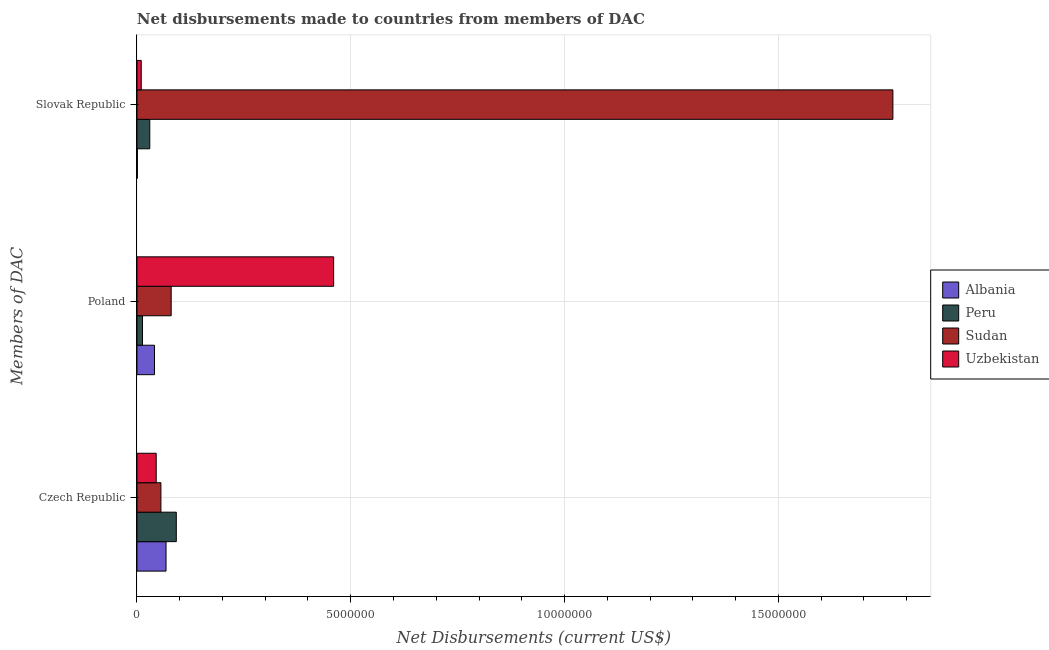Are the number of bars on each tick of the Y-axis equal?
Keep it short and to the point. Yes. What is the label of the 3rd group of bars from the top?
Keep it short and to the point. Czech Republic. What is the net disbursements made by slovak republic in Uzbekistan?
Provide a short and direct response. 1.00e+05. Across all countries, what is the maximum net disbursements made by czech republic?
Ensure brevity in your answer.  9.20e+05. Across all countries, what is the minimum net disbursements made by czech republic?
Your answer should be very brief. 4.50e+05. In which country was the net disbursements made by slovak republic maximum?
Your answer should be compact. Sudan. What is the total net disbursements made by czech republic in the graph?
Make the answer very short. 2.61e+06. What is the difference between the net disbursements made by poland in Sudan and that in Albania?
Your response must be concise. 3.90e+05. What is the difference between the net disbursements made by slovak republic in Peru and the net disbursements made by poland in Sudan?
Offer a terse response. -5.00e+05. What is the average net disbursements made by czech republic per country?
Give a very brief answer. 6.52e+05. What is the difference between the net disbursements made by czech republic and net disbursements made by slovak republic in Albania?
Your response must be concise. 6.70e+05. In how many countries, is the net disbursements made by slovak republic greater than 15000000 US$?
Offer a very short reply. 1. What is the ratio of the net disbursements made by slovak republic in Albania to that in Sudan?
Your answer should be very brief. 0. What is the difference between the highest and the lowest net disbursements made by czech republic?
Your response must be concise. 4.70e+05. In how many countries, is the net disbursements made by czech republic greater than the average net disbursements made by czech republic taken over all countries?
Provide a short and direct response. 2. Is the sum of the net disbursements made by poland in Peru and Albania greater than the maximum net disbursements made by slovak republic across all countries?
Your answer should be compact. No. What does the 1st bar from the top in Poland represents?
Make the answer very short. Uzbekistan. What does the 1st bar from the bottom in Czech Republic represents?
Ensure brevity in your answer.  Albania. Is it the case that in every country, the sum of the net disbursements made by czech republic and net disbursements made by poland is greater than the net disbursements made by slovak republic?
Provide a succinct answer. No. How many bars are there?
Provide a succinct answer. 12. Are all the bars in the graph horizontal?
Provide a succinct answer. Yes. Are the values on the major ticks of X-axis written in scientific E-notation?
Make the answer very short. No. Where does the legend appear in the graph?
Your response must be concise. Center right. What is the title of the graph?
Make the answer very short. Net disbursements made to countries from members of DAC. What is the label or title of the X-axis?
Provide a succinct answer. Net Disbursements (current US$). What is the label or title of the Y-axis?
Provide a succinct answer. Members of DAC. What is the Net Disbursements (current US$) in Albania in Czech Republic?
Make the answer very short. 6.80e+05. What is the Net Disbursements (current US$) in Peru in Czech Republic?
Your response must be concise. 9.20e+05. What is the Net Disbursements (current US$) of Sudan in Czech Republic?
Make the answer very short. 5.60e+05. What is the Net Disbursements (current US$) of Uzbekistan in Czech Republic?
Keep it short and to the point. 4.50e+05. What is the Net Disbursements (current US$) of Albania in Poland?
Your answer should be very brief. 4.10e+05. What is the Net Disbursements (current US$) in Peru in Poland?
Provide a succinct answer. 1.30e+05. What is the Net Disbursements (current US$) in Uzbekistan in Poland?
Your answer should be compact. 4.60e+06. What is the Net Disbursements (current US$) of Peru in Slovak Republic?
Your answer should be compact. 3.00e+05. What is the Net Disbursements (current US$) of Sudan in Slovak Republic?
Your answer should be compact. 1.77e+07. Across all Members of DAC, what is the maximum Net Disbursements (current US$) in Albania?
Offer a very short reply. 6.80e+05. Across all Members of DAC, what is the maximum Net Disbursements (current US$) in Peru?
Offer a very short reply. 9.20e+05. Across all Members of DAC, what is the maximum Net Disbursements (current US$) in Sudan?
Provide a short and direct response. 1.77e+07. Across all Members of DAC, what is the maximum Net Disbursements (current US$) in Uzbekistan?
Make the answer very short. 4.60e+06. Across all Members of DAC, what is the minimum Net Disbursements (current US$) of Albania?
Offer a terse response. 10000. Across all Members of DAC, what is the minimum Net Disbursements (current US$) of Sudan?
Provide a short and direct response. 5.60e+05. Across all Members of DAC, what is the minimum Net Disbursements (current US$) in Uzbekistan?
Ensure brevity in your answer.  1.00e+05. What is the total Net Disbursements (current US$) of Albania in the graph?
Provide a short and direct response. 1.10e+06. What is the total Net Disbursements (current US$) in Peru in the graph?
Your answer should be compact. 1.35e+06. What is the total Net Disbursements (current US$) of Sudan in the graph?
Give a very brief answer. 1.90e+07. What is the total Net Disbursements (current US$) of Uzbekistan in the graph?
Keep it short and to the point. 5.15e+06. What is the difference between the Net Disbursements (current US$) in Albania in Czech Republic and that in Poland?
Your answer should be compact. 2.70e+05. What is the difference between the Net Disbursements (current US$) in Peru in Czech Republic and that in Poland?
Offer a terse response. 7.90e+05. What is the difference between the Net Disbursements (current US$) of Uzbekistan in Czech Republic and that in Poland?
Offer a very short reply. -4.15e+06. What is the difference between the Net Disbursements (current US$) of Albania in Czech Republic and that in Slovak Republic?
Provide a succinct answer. 6.70e+05. What is the difference between the Net Disbursements (current US$) of Peru in Czech Republic and that in Slovak Republic?
Keep it short and to the point. 6.20e+05. What is the difference between the Net Disbursements (current US$) in Sudan in Czech Republic and that in Slovak Republic?
Keep it short and to the point. -1.71e+07. What is the difference between the Net Disbursements (current US$) in Uzbekistan in Czech Republic and that in Slovak Republic?
Make the answer very short. 3.50e+05. What is the difference between the Net Disbursements (current US$) in Albania in Poland and that in Slovak Republic?
Provide a short and direct response. 4.00e+05. What is the difference between the Net Disbursements (current US$) in Peru in Poland and that in Slovak Republic?
Keep it short and to the point. -1.70e+05. What is the difference between the Net Disbursements (current US$) in Sudan in Poland and that in Slovak Republic?
Offer a very short reply. -1.69e+07. What is the difference between the Net Disbursements (current US$) in Uzbekistan in Poland and that in Slovak Republic?
Provide a short and direct response. 4.50e+06. What is the difference between the Net Disbursements (current US$) in Albania in Czech Republic and the Net Disbursements (current US$) in Peru in Poland?
Offer a terse response. 5.50e+05. What is the difference between the Net Disbursements (current US$) in Albania in Czech Republic and the Net Disbursements (current US$) in Uzbekistan in Poland?
Ensure brevity in your answer.  -3.92e+06. What is the difference between the Net Disbursements (current US$) in Peru in Czech Republic and the Net Disbursements (current US$) in Sudan in Poland?
Give a very brief answer. 1.20e+05. What is the difference between the Net Disbursements (current US$) in Peru in Czech Republic and the Net Disbursements (current US$) in Uzbekistan in Poland?
Provide a succinct answer. -3.68e+06. What is the difference between the Net Disbursements (current US$) of Sudan in Czech Republic and the Net Disbursements (current US$) of Uzbekistan in Poland?
Offer a terse response. -4.04e+06. What is the difference between the Net Disbursements (current US$) of Albania in Czech Republic and the Net Disbursements (current US$) of Peru in Slovak Republic?
Make the answer very short. 3.80e+05. What is the difference between the Net Disbursements (current US$) of Albania in Czech Republic and the Net Disbursements (current US$) of Sudan in Slovak Republic?
Provide a succinct answer. -1.70e+07. What is the difference between the Net Disbursements (current US$) in Albania in Czech Republic and the Net Disbursements (current US$) in Uzbekistan in Slovak Republic?
Make the answer very short. 5.80e+05. What is the difference between the Net Disbursements (current US$) in Peru in Czech Republic and the Net Disbursements (current US$) in Sudan in Slovak Republic?
Offer a terse response. -1.68e+07. What is the difference between the Net Disbursements (current US$) of Peru in Czech Republic and the Net Disbursements (current US$) of Uzbekistan in Slovak Republic?
Your response must be concise. 8.20e+05. What is the difference between the Net Disbursements (current US$) in Sudan in Czech Republic and the Net Disbursements (current US$) in Uzbekistan in Slovak Republic?
Provide a short and direct response. 4.60e+05. What is the difference between the Net Disbursements (current US$) of Albania in Poland and the Net Disbursements (current US$) of Sudan in Slovak Republic?
Your response must be concise. -1.73e+07. What is the difference between the Net Disbursements (current US$) of Albania in Poland and the Net Disbursements (current US$) of Uzbekistan in Slovak Republic?
Your answer should be very brief. 3.10e+05. What is the difference between the Net Disbursements (current US$) in Peru in Poland and the Net Disbursements (current US$) in Sudan in Slovak Republic?
Keep it short and to the point. -1.76e+07. What is the difference between the Net Disbursements (current US$) in Peru in Poland and the Net Disbursements (current US$) in Uzbekistan in Slovak Republic?
Offer a terse response. 3.00e+04. What is the average Net Disbursements (current US$) of Albania per Members of DAC?
Give a very brief answer. 3.67e+05. What is the average Net Disbursements (current US$) of Sudan per Members of DAC?
Provide a succinct answer. 6.35e+06. What is the average Net Disbursements (current US$) of Uzbekistan per Members of DAC?
Make the answer very short. 1.72e+06. What is the difference between the Net Disbursements (current US$) of Albania and Net Disbursements (current US$) of Peru in Czech Republic?
Provide a succinct answer. -2.40e+05. What is the difference between the Net Disbursements (current US$) in Albania and Net Disbursements (current US$) in Sudan in Czech Republic?
Keep it short and to the point. 1.20e+05. What is the difference between the Net Disbursements (current US$) of Albania and Net Disbursements (current US$) of Uzbekistan in Czech Republic?
Provide a short and direct response. 2.30e+05. What is the difference between the Net Disbursements (current US$) of Peru and Net Disbursements (current US$) of Sudan in Czech Republic?
Your response must be concise. 3.60e+05. What is the difference between the Net Disbursements (current US$) of Sudan and Net Disbursements (current US$) of Uzbekistan in Czech Republic?
Your answer should be very brief. 1.10e+05. What is the difference between the Net Disbursements (current US$) of Albania and Net Disbursements (current US$) of Peru in Poland?
Your answer should be compact. 2.80e+05. What is the difference between the Net Disbursements (current US$) in Albania and Net Disbursements (current US$) in Sudan in Poland?
Your answer should be compact. -3.90e+05. What is the difference between the Net Disbursements (current US$) in Albania and Net Disbursements (current US$) in Uzbekistan in Poland?
Your response must be concise. -4.19e+06. What is the difference between the Net Disbursements (current US$) of Peru and Net Disbursements (current US$) of Sudan in Poland?
Your answer should be compact. -6.70e+05. What is the difference between the Net Disbursements (current US$) of Peru and Net Disbursements (current US$) of Uzbekistan in Poland?
Ensure brevity in your answer.  -4.47e+06. What is the difference between the Net Disbursements (current US$) in Sudan and Net Disbursements (current US$) in Uzbekistan in Poland?
Offer a terse response. -3.80e+06. What is the difference between the Net Disbursements (current US$) in Albania and Net Disbursements (current US$) in Sudan in Slovak Republic?
Your answer should be compact. -1.77e+07. What is the difference between the Net Disbursements (current US$) of Peru and Net Disbursements (current US$) of Sudan in Slovak Republic?
Your answer should be very brief. -1.74e+07. What is the difference between the Net Disbursements (current US$) of Peru and Net Disbursements (current US$) of Uzbekistan in Slovak Republic?
Provide a short and direct response. 2.00e+05. What is the difference between the Net Disbursements (current US$) of Sudan and Net Disbursements (current US$) of Uzbekistan in Slovak Republic?
Your response must be concise. 1.76e+07. What is the ratio of the Net Disbursements (current US$) of Albania in Czech Republic to that in Poland?
Provide a short and direct response. 1.66. What is the ratio of the Net Disbursements (current US$) in Peru in Czech Republic to that in Poland?
Your answer should be compact. 7.08. What is the ratio of the Net Disbursements (current US$) in Uzbekistan in Czech Republic to that in Poland?
Give a very brief answer. 0.1. What is the ratio of the Net Disbursements (current US$) of Peru in Czech Republic to that in Slovak Republic?
Keep it short and to the point. 3.07. What is the ratio of the Net Disbursements (current US$) of Sudan in Czech Republic to that in Slovak Republic?
Give a very brief answer. 0.03. What is the ratio of the Net Disbursements (current US$) in Albania in Poland to that in Slovak Republic?
Provide a short and direct response. 41. What is the ratio of the Net Disbursements (current US$) in Peru in Poland to that in Slovak Republic?
Provide a short and direct response. 0.43. What is the ratio of the Net Disbursements (current US$) in Sudan in Poland to that in Slovak Republic?
Ensure brevity in your answer.  0.05. What is the difference between the highest and the second highest Net Disbursements (current US$) in Peru?
Your answer should be compact. 6.20e+05. What is the difference between the highest and the second highest Net Disbursements (current US$) of Sudan?
Your response must be concise. 1.69e+07. What is the difference between the highest and the second highest Net Disbursements (current US$) in Uzbekistan?
Your answer should be very brief. 4.15e+06. What is the difference between the highest and the lowest Net Disbursements (current US$) in Albania?
Offer a very short reply. 6.70e+05. What is the difference between the highest and the lowest Net Disbursements (current US$) of Peru?
Make the answer very short. 7.90e+05. What is the difference between the highest and the lowest Net Disbursements (current US$) of Sudan?
Provide a short and direct response. 1.71e+07. What is the difference between the highest and the lowest Net Disbursements (current US$) in Uzbekistan?
Your answer should be compact. 4.50e+06. 